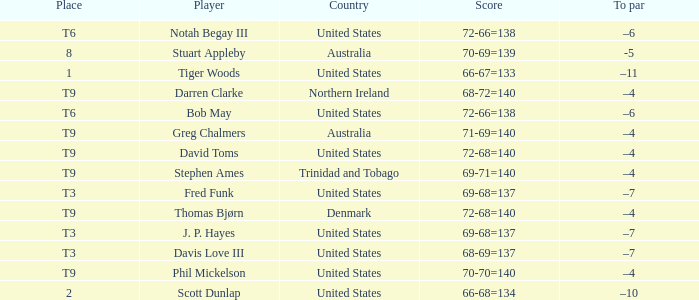What country is Stephen Ames from with a place value of t9? Trinidad and Tobago. 